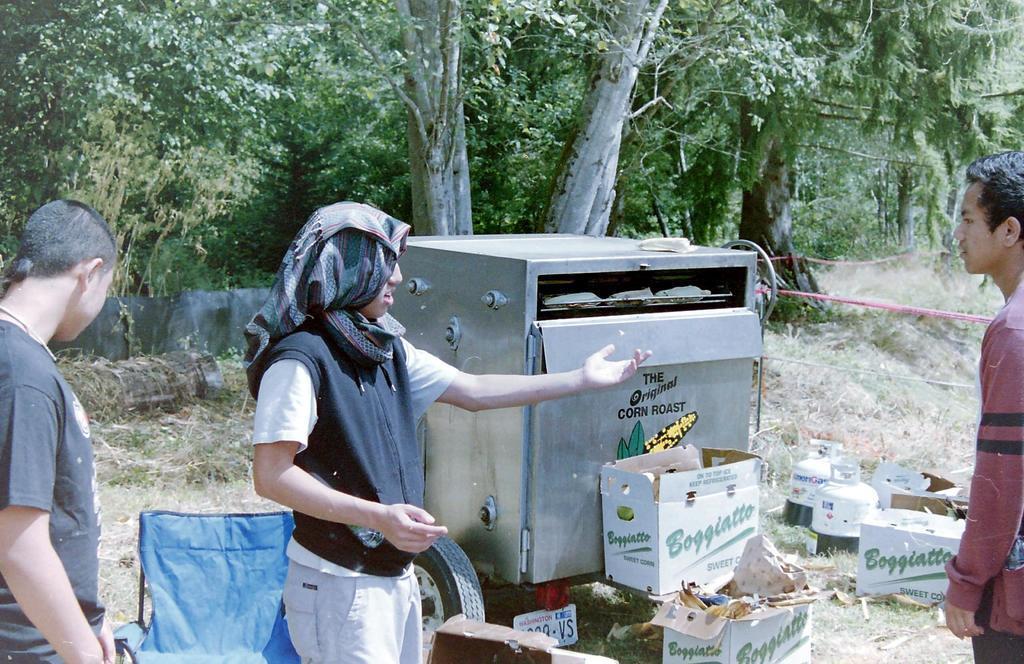Please provide a concise description of this image. In the image I can see three people, among them a person is wearing cloth on the head and also I can see some trees, plants, boxes and a machine. 